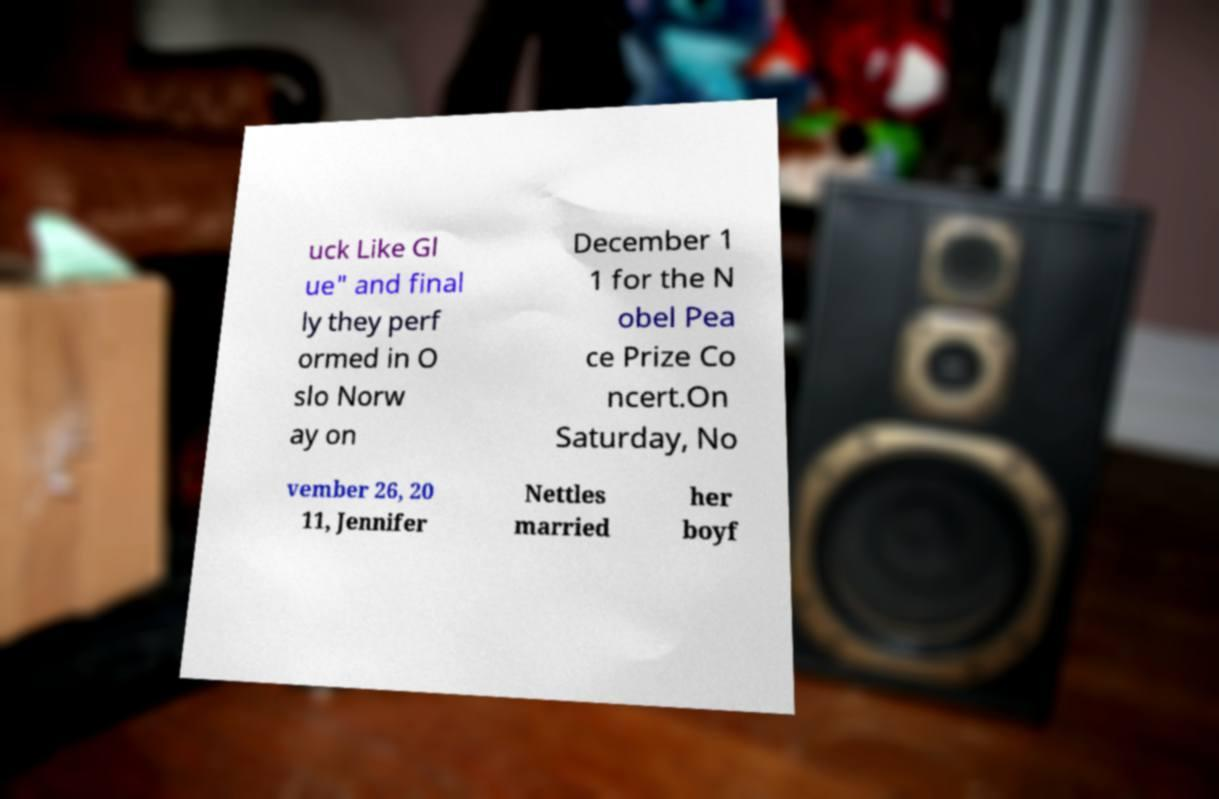What messages or text are displayed in this image? I need them in a readable, typed format. uck Like Gl ue" and final ly they perf ormed in O slo Norw ay on December 1 1 for the N obel Pea ce Prize Co ncert.On Saturday, No vember 26, 20 11, Jennifer Nettles married her boyf 